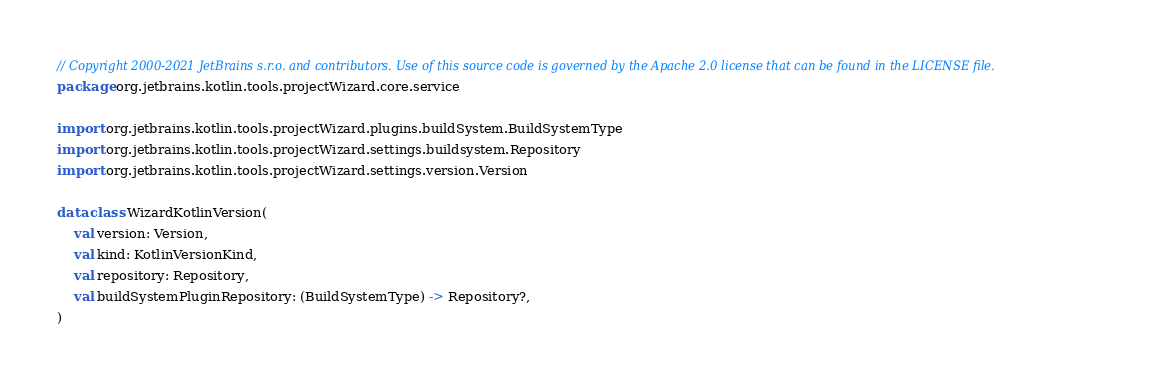Convert code to text. <code><loc_0><loc_0><loc_500><loc_500><_Kotlin_>// Copyright 2000-2021 JetBrains s.r.o. and contributors. Use of this source code is governed by the Apache 2.0 license that can be found in the LICENSE file.
package org.jetbrains.kotlin.tools.projectWizard.core.service

import org.jetbrains.kotlin.tools.projectWizard.plugins.buildSystem.BuildSystemType
import org.jetbrains.kotlin.tools.projectWizard.settings.buildsystem.Repository
import org.jetbrains.kotlin.tools.projectWizard.settings.version.Version

data class WizardKotlinVersion(
    val version: Version,
    val kind: KotlinVersionKind,
    val repository: Repository,
    val buildSystemPluginRepository: (BuildSystemType) -> Repository?,
)</code> 